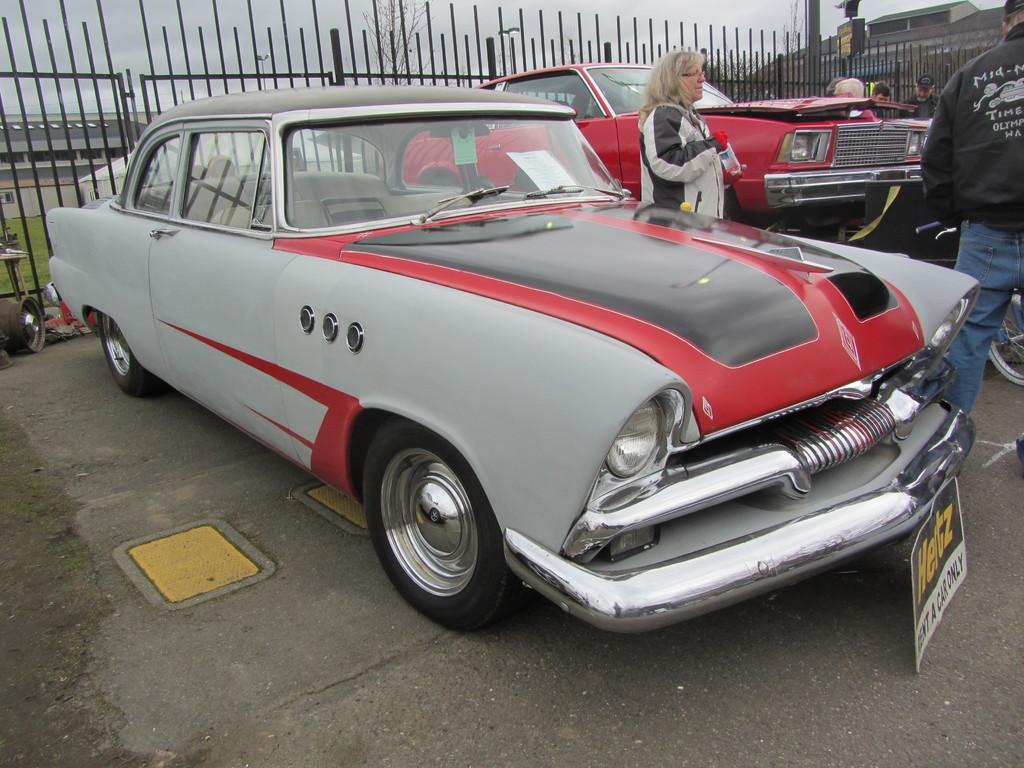What is parked on the road in the image? There is a car parked on the road in the image. What color is the car? The car is grey in color. Who is present in the scene? A woman is standing in the middle of the scene. What is located behind the car and the woman? There is an iron grill behind the car and the woman. How many cushions are on the bridge in the image? There is no bridge or cushions present in the image. What type of mine is visible in the background of the image? There is no mine present in the image. 